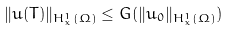Convert formula to latex. <formula><loc_0><loc_0><loc_500><loc_500>\| u ( T ) \| _ { H ^ { 1 } _ { x } ( \Omega ) } \leq G ( \| u _ { 0 } \| _ { H ^ { 1 } _ { x } ( \Omega ) } )</formula> 